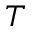<formula> <loc_0><loc_0><loc_500><loc_500>T</formula> 